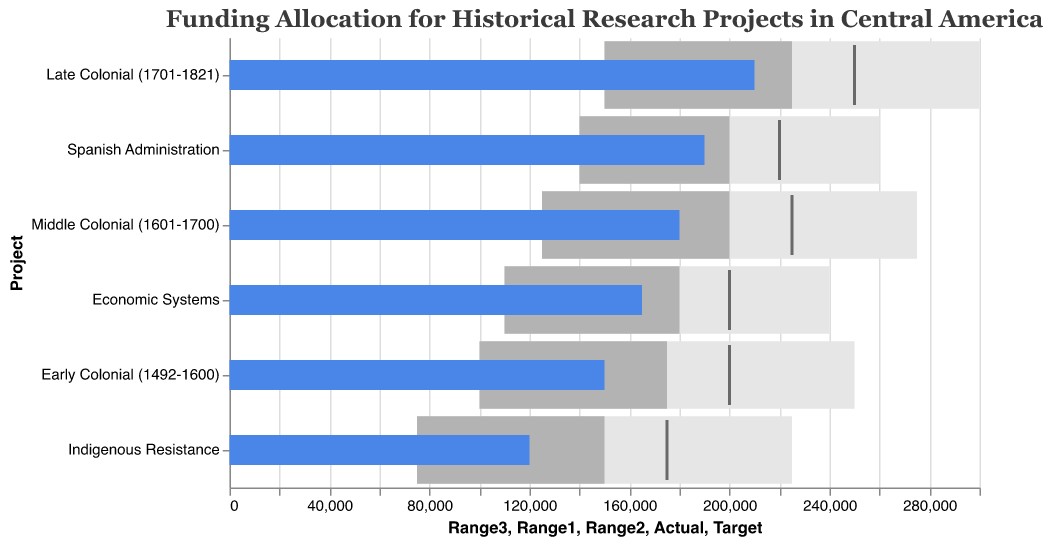What is the project with the highest actual funding allocation? The project with the highest actual funding allocation has a bar that extends furthest on the x-axis. This project is "Late Colonial (1701-1821)" with an actual funding of 210,000.
Answer: Late Colonial (1701-1821) Which period received the least funding compared to its target? To determine this, we need to look at the difference between actual and target funding for each project. "Indigenous Resistance" received 120,000 compared to a target of 175,000, which is the largest shortfall of 55,000.
Answer: Indigenous Resistance Does the "Spanish Administration" project meet its target funding allocation? The black tick mark represents the target funding. For "Spanish Administration," the actual funding bar (blue) ends before the tick mark, meaning it does not meet its target of 220,000 with actual funding of 190,000.
Answer: No Which project has the smallest range of satisfactory funding levels (Range1 to Range3)? To find this, look at the difference between Range1 and Range3 for each project. "Economic Systems" has the smallest range from 110,000 to 240,000, a difference of 130,000.
Answer: Economic Systems By how much does the actual funding for the "Early Colonial (1492-1600)" project fall short of its target? Subtract the actual funding from the target funding for "Early Colonial (1492-1600)" to find the shortfall. Target 200,000 - Actual 150,000 = 50,000 shortfall.
Answer: 50,000 Between "Middle Colonial (1601-1700)" and "Economic Systems," which project is closer to its target funding allocation? Compare the difference between actual and target funding. "Middle Colonial" has an actual of 180,000 and target of 225,000. The shortfall is 45,000. "Economic Systems" has an actual of 165,000 and target of 200,000. The shortfall is 35,000. Thus, "Economic Systems" is closer to its target.
Answer: Economic Systems What is the average actual funding allocation across all projects? Add the actual funding for all projects and divide by the number of projects. Sum = 150,000 + 180,000 + 210,000 + 120,000 + 190,000 + 165,000 = 1,015,000. Divide by 6 projects. 1,015,000 / 6 = 169,167.
Answer: 169,167 How many projects received actual funding within their second range of satisfactory levels? Identify projects where the actual funding falls between Range1 and Range2. "Early Colonial," "Middle Colonial," "Late Colonial," "Spanish Administration," and "Economic Systems" all meet this criterion. Thus, 5 projects received funding within their second range.
Answer: 5 